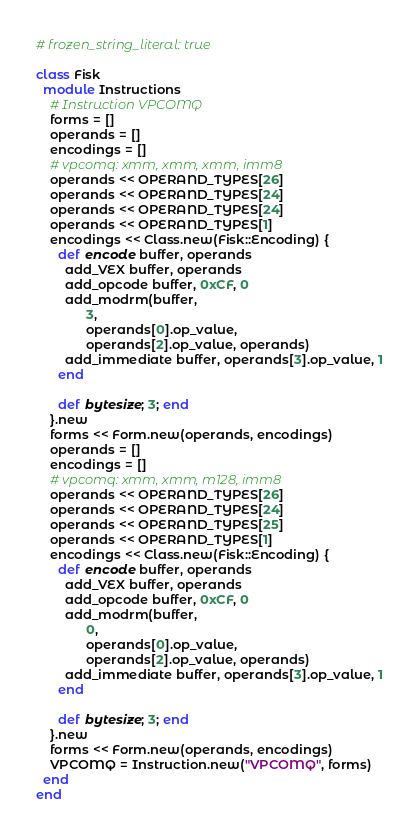<code> <loc_0><loc_0><loc_500><loc_500><_Ruby_># frozen_string_literal: true

class Fisk
  module Instructions
    # Instruction VPCOMQ
    forms = []
    operands = []
    encodings = []
    # vpcomq: xmm, xmm, xmm, imm8
    operands << OPERAND_TYPES[26]
    operands << OPERAND_TYPES[24]
    operands << OPERAND_TYPES[24]
    operands << OPERAND_TYPES[1]
    encodings << Class.new(Fisk::Encoding) {
      def encode buffer, operands
        add_VEX buffer, operands
        add_opcode buffer, 0xCF, 0
        add_modrm(buffer,
              3,
              operands[0].op_value,
              operands[2].op_value, operands)
        add_immediate buffer, operands[3].op_value, 1
      end

      def bytesize; 3; end
    }.new
    forms << Form.new(operands, encodings)
    operands = []
    encodings = []
    # vpcomq: xmm, xmm, m128, imm8
    operands << OPERAND_TYPES[26]
    operands << OPERAND_TYPES[24]
    operands << OPERAND_TYPES[25]
    operands << OPERAND_TYPES[1]
    encodings << Class.new(Fisk::Encoding) {
      def encode buffer, operands
        add_VEX buffer, operands
        add_opcode buffer, 0xCF, 0
        add_modrm(buffer,
              0,
              operands[0].op_value,
              operands[2].op_value, operands)
        add_immediate buffer, operands[3].op_value, 1
      end

      def bytesize; 3; end
    }.new
    forms << Form.new(operands, encodings)
    VPCOMQ = Instruction.new("VPCOMQ", forms)
  end
end
</code> 